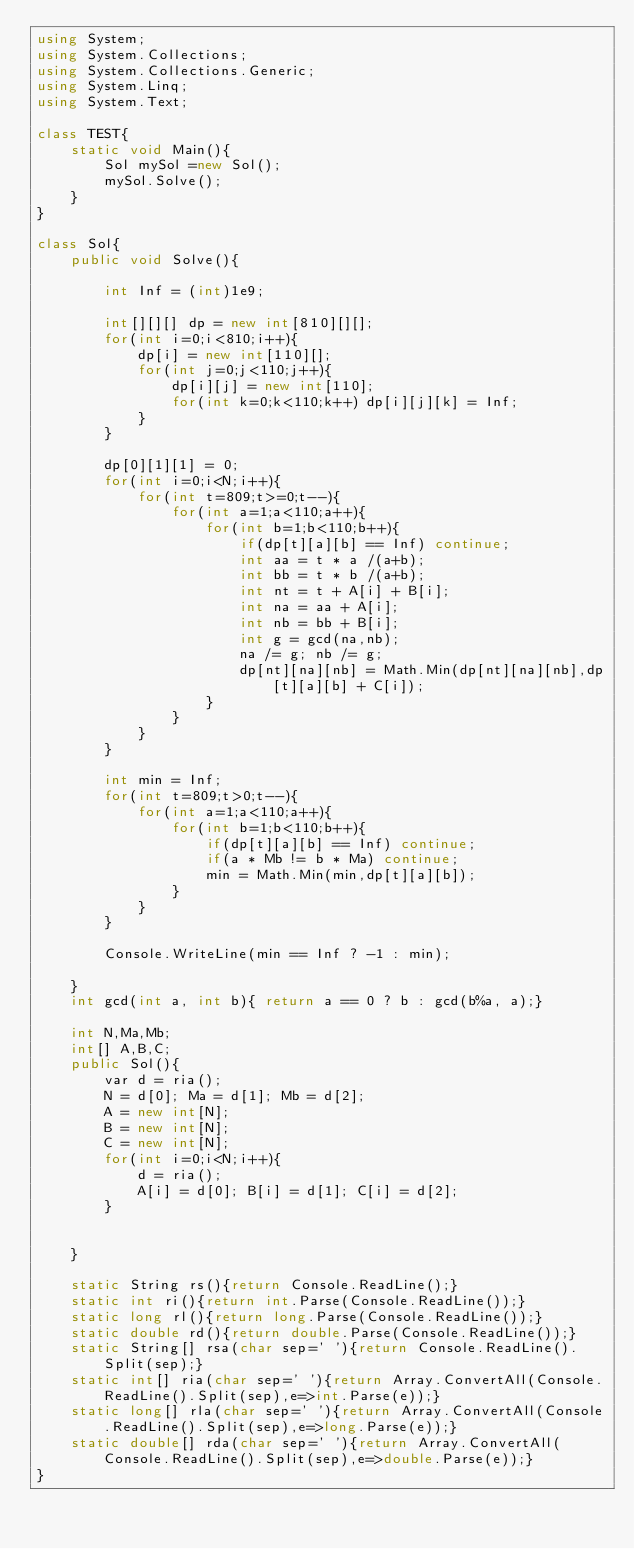Convert code to text. <code><loc_0><loc_0><loc_500><loc_500><_C#_>using System;
using System.Collections;
using System.Collections.Generic;
using System.Linq;
using System.Text;

class TEST{
	static void Main(){
		Sol mySol =new Sol();
		mySol.Solve();
	}
}

class Sol{
	public void Solve(){
		
		int Inf = (int)1e9;
		
		int[][][] dp = new int[810][][];
		for(int i=0;i<810;i++){
			dp[i] = new int[110][];
			for(int j=0;j<110;j++){
				dp[i][j] = new int[110];
				for(int k=0;k<110;k++) dp[i][j][k] = Inf;
			}
		}
		
		dp[0][1][1] = 0;
		for(int i=0;i<N;i++){
			for(int t=809;t>=0;t--){
				for(int a=1;a<110;a++){
					for(int b=1;b<110;b++){
						if(dp[t][a][b] == Inf) continue;
						int aa = t * a /(a+b);
						int bb = t * b /(a+b);
						int nt = t + A[i] + B[i];
						int na = aa + A[i];
						int nb = bb + B[i];
						int g = gcd(na,nb);
						na /= g; nb /= g;
						dp[nt][na][nb] = Math.Min(dp[nt][na][nb],dp[t][a][b] + C[i]);
					}
				}
			}
		}
		
		int min = Inf;
		for(int t=809;t>0;t--){
			for(int a=1;a<110;a++){
				for(int b=1;b<110;b++){
					if(dp[t][a][b] == Inf) continue;
					if(a * Mb != b * Ma) continue;
					min = Math.Min(min,dp[t][a][b]);
				}
			}
		}
		
		Console.WriteLine(min == Inf ? -1 : min);
		
	}
	int gcd(int a, int b){ return a == 0 ? b : gcd(b%a, a);}
	
	int N,Ma,Mb;
	int[] A,B,C;
	public Sol(){
		var d = ria();
		N = d[0]; Ma = d[1]; Mb = d[2];
		A = new int[N];
		B = new int[N];
		C = new int[N];
		for(int i=0;i<N;i++){
			d = ria();
			A[i] = d[0]; B[i] = d[1]; C[i] = d[2];
		}
		
		
	}

	static String rs(){return Console.ReadLine();}
	static int ri(){return int.Parse(Console.ReadLine());}
	static long rl(){return long.Parse(Console.ReadLine());}
	static double rd(){return double.Parse(Console.ReadLine());}
	static String[] rsa(char sep=' '){return Console.ReadLine().Split(sep);}
	static int[] ria(char sep=' '){return Array.ConvertAll(Console.ReadLine().Split(sep),e=>int.Parse(e));}
	static long[] rla(char sep=' '){return Array.ConvertAll(Console.ReadLine().Split(sep),e=>long.Parse(e));}
	static double[] rda(char sep=' '){return Array.ConvertAll(Console.ReadLine().Split(sep),e=>double.Parse(e));}
}
</code> 